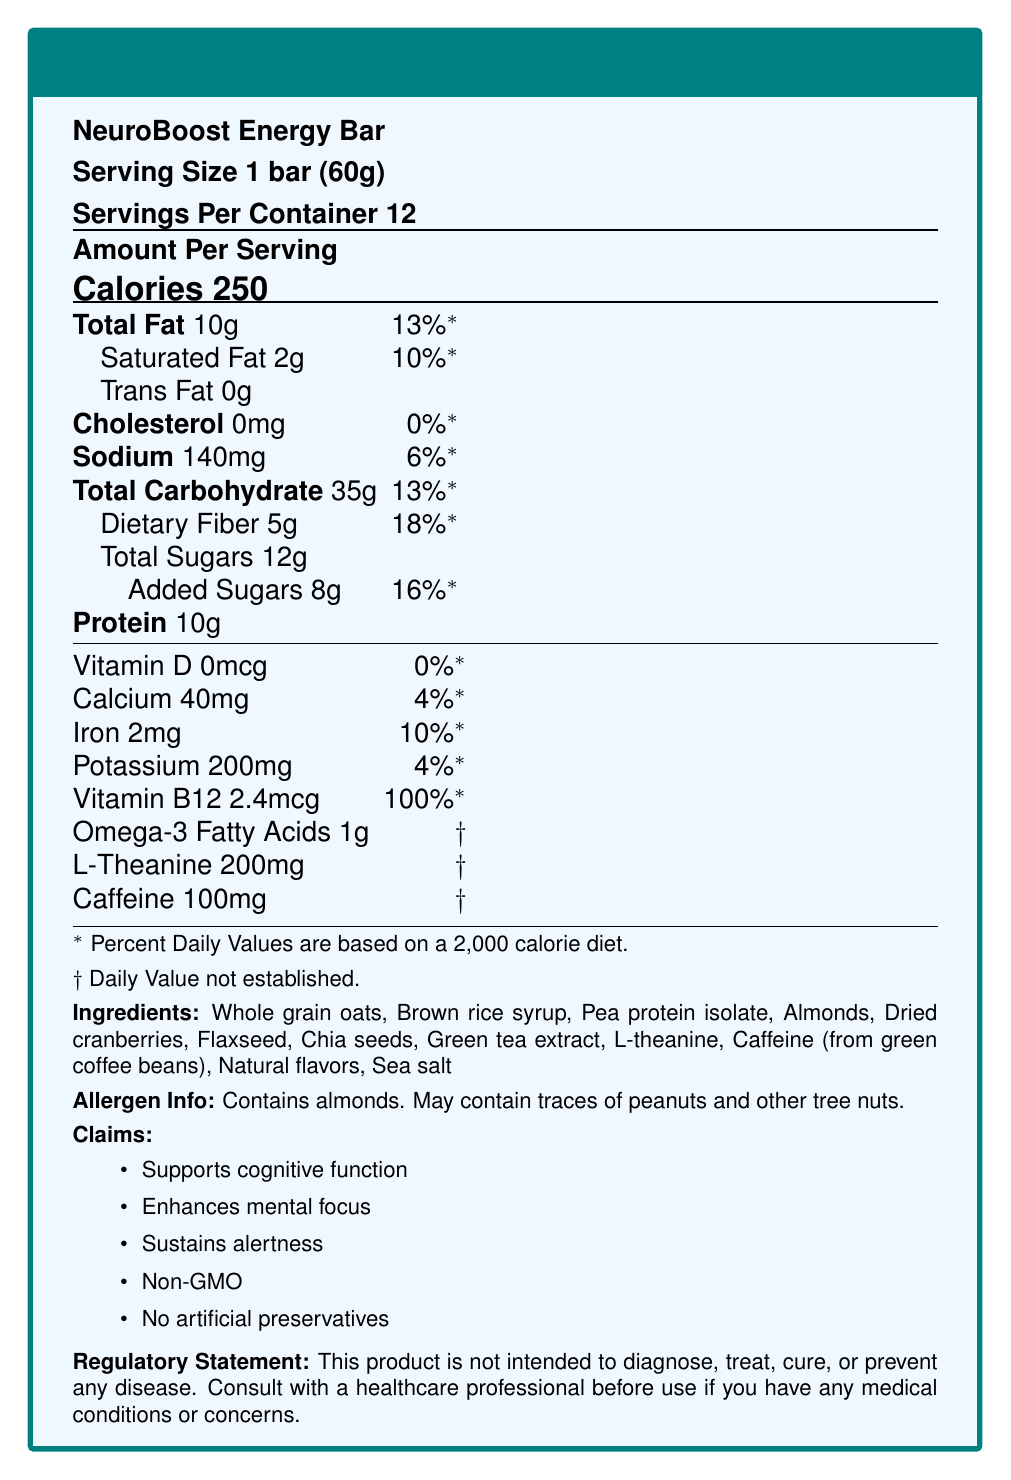what is the serving size of the NeuroBoost Energy Bar? The serving size is explicitly mentioned as "1 bar (60g)" on the label.
Answer: 1 bar (60g) How many calories are in one serving of the NeuroBoost Energy Bar? The document shows that there are 250 calories per serving of the NeuroBoost Energy Bar.
Answer: 250 What is the total amount of dietary fiber in one serving? The total dietary fiber per serving is provided as 5g.
Answer: 5g How much vitamin B12 is in one serving and what is its daily value percentage? One serving contains 2.4mcg of vitamin B12, which is 100% of the daily value.
Answer: 2.4mcg, 100% List two ingredients that contribute to the protein content of the bar. Pea protein isolate and almonds are ingredients that contribute to the protein content.
Answer: Pea protein isolate, Almonds How much caffeine is in one serving of the NeuroBoost Energy Bar? The document states that each serving contains 100mg of caffeine.
Answer: 100mg How much iron is in one serving and what is its daily value percentage? Each serving contains 2mg of iron, which is 10% of the daily value.
Answer: 2mg, 10% Which of the following claims is NOT made by the NeuroBoost Energy Bar? A. Supports cognitive function B. Enhances physical endurance C. Sustains alertness D. Non-GMO The claims listed in the document do not include "Enhances physical endurance."
Answer: B What is the total fat amount per serving? A. 0g B. 10g C. 2g D. 5g The total fat amount per serving is 10g as shown in the document.
Answer: B Does the NeuroBoost Energy Bar contain any artificial preservatives? The document claims "No artificial preservatives" as one of the benefits.
Answer: No Does the NeuroBoost Energy Bar contain any allergens? The bar contains almonds, and the allergen info notes it may contain traces of peanuts and other tree nuts.
Answer: Yes Summarize the main idea of the Nutrition Facts Label for the NeuroBoost Energy Bar. The summary captures the product purpose, key ingredients, nutritional contents, and allergen information, which are all detailed in the document.
Answer: The NeuroBoost Energy Bar is designed to support cognitive functions, enhance mental focus, and sustain alertness. It contains 250 calories per serving with key ingredients like whole grain oats, pea protein isolate, and green tea extract. The bar provides additional nutrients like vitamin B12, Omega-3 fatty acids, L-theanine, and caffeine. It is non-GMO and does not contain artificial preservatives, though it does contain almonds and may have traces of other nuts. What is the source of caffeine in the NeuroBoost Energy Bar? The document states that caffeine is derived from green coffee beans.
Answer: Green coffee beans Is the daily value percentage for Omega-3 fatty acids established in the document? The document indicates "* Daily Value not established" for Omega-3 fatty acids.
Answer: No What are the total sugars in one serving, including added sugars? The document specifies total sugars as 12g and added sugars as 8g per serving.
Answer: 12g (Total Sugars), 8g (Added Sugars) What is the regulatory statement on the NeuroBoost Energy Bar's label? The regulatory statement clarifies that the product is not for diagnosing, treating, curing, or preventing diseases and suggests consulting a healthcare professional.
Answer: "This product is not intended to diagnose, treat, cure, or prevent any disease. Consult with a healthcare professional before use if you have any medical conditions or concerns." What is the daily value percentage for sodium in one serving? The document indicates that one serving has 140mg of sodium, which is 6% of the daily value.
Answer: 6% How does the NeuroBoost Energy Bar help BCI developers? The document lists several benefits like supporting cognitive function and enhancing focus, but it doesn't explain specifically how it helps BCI developers.
Answer: Not enough information 